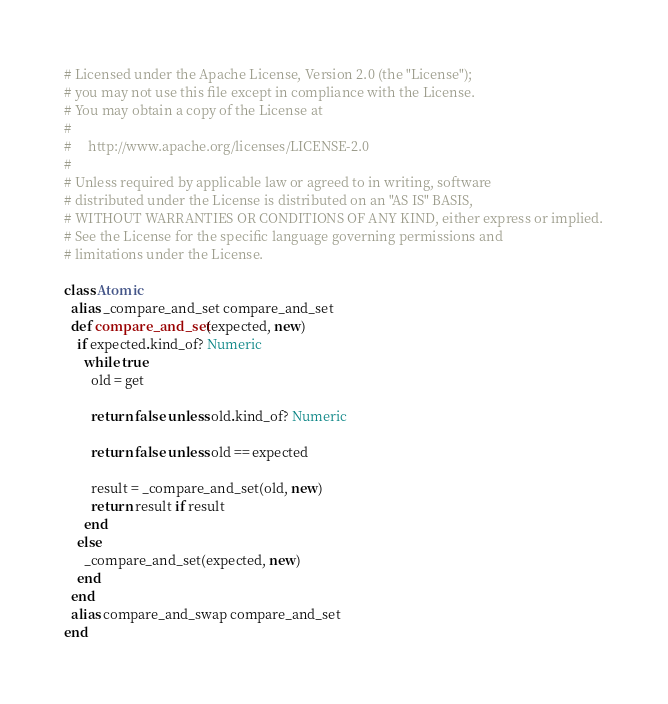<code> <loc_0><loc_0><loc_500><loc_500><_Ruby_># Licensed under the Apache License, Version 2.0 (the "License");
# you may not use this file except in compliance with the License.
# You may obtain a copy of the License at
#
#     http://www.apache.org/licenses/LICENSE-2.0
#
# Unless required by applicable law or agreed to in writing, software
# distributed under the License is distributed on an "AS IS" BASIS,
# WITHOUT WARRANTIES OR CONDITIONS OF ANY KIND, either express or implied.
# See the License for the specific language governing permissions and
# limitations under the License.

class Atomic
  alias _compare_and_set compare_and_set
  def compare_and_set(expected, new)
    if expected.kind_of? Numeric
      while true
        old = get
        
        return false unless old.kind_of? Numeric
        
        return false unless old == expected
        
        result = _compare_and_set(old, new)
        return result if result
      end
    else
      _compare_and_set(expected, new)
    end
  end
  alias compare_and_swap compare_and_set
end</code> 